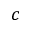Convert formula to latex. <formula><loc_0><loc_0><loc_500><loc_500>c</formula> 